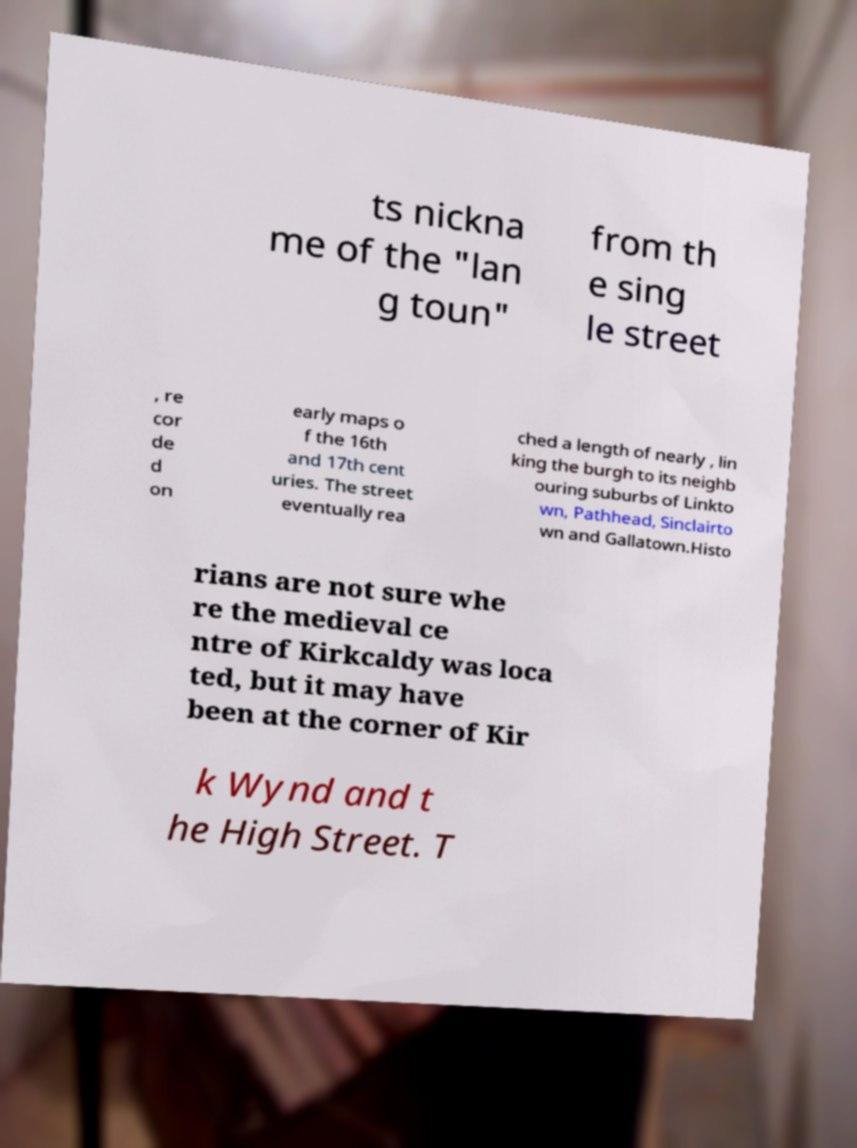Could you assist in decoding the text presented in this image and type it out clearly? ts nickna me of the "lan g toun" from th e sing le street , re cor de d on early maps o f the 16th and 17th cent uries. The street eventually rea ched a length of nearly , lin king the burgh to its neighb ouring suburbs of Linkto wn, Pathhead, Sinclairto wn and Gallatown.Histo rians are not sure whe re the medieval ce ntre of Kirkcaldy was loca ted, but it may have been at the corner of Kir k Wynd and t he High Street. T 